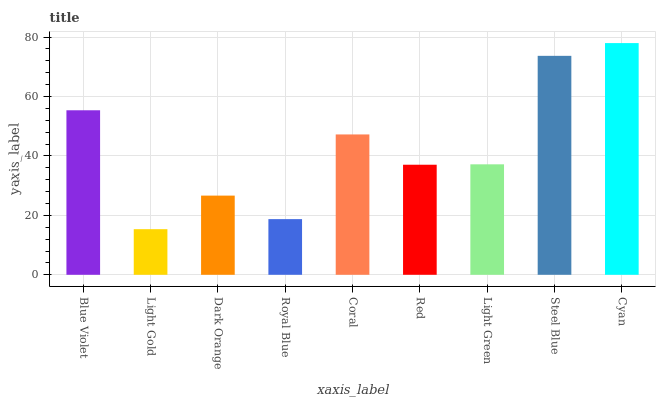Is Light Gold the minimum?
Answer yes or no. Yes. Is Cyan the maximum?
Answer yes or no. Yes. Is Dark Orange the minimum?
Answer yes or no. No. Is Dark Orange the maximum?
Answer yes or no. No. Is Dark Orange greater than Light Gold?
Answer yes or no. Yes. Is Light Gold less than Dark Orange?
Answer yes or no. Yes. Is Light Gold greater than Dark Orange?
Answer yes or no. No. Is Dark Orange less than Light Gold?
Answer yes or no. No. Is Light Green the high median?
Answer yes or no. Yes. Is Light Green the low median?
Answer yes or no. Yes. Is Blue Violet the high median?
Answer yes or no. No. Is Red the low median?
Answer yes or no. No. 